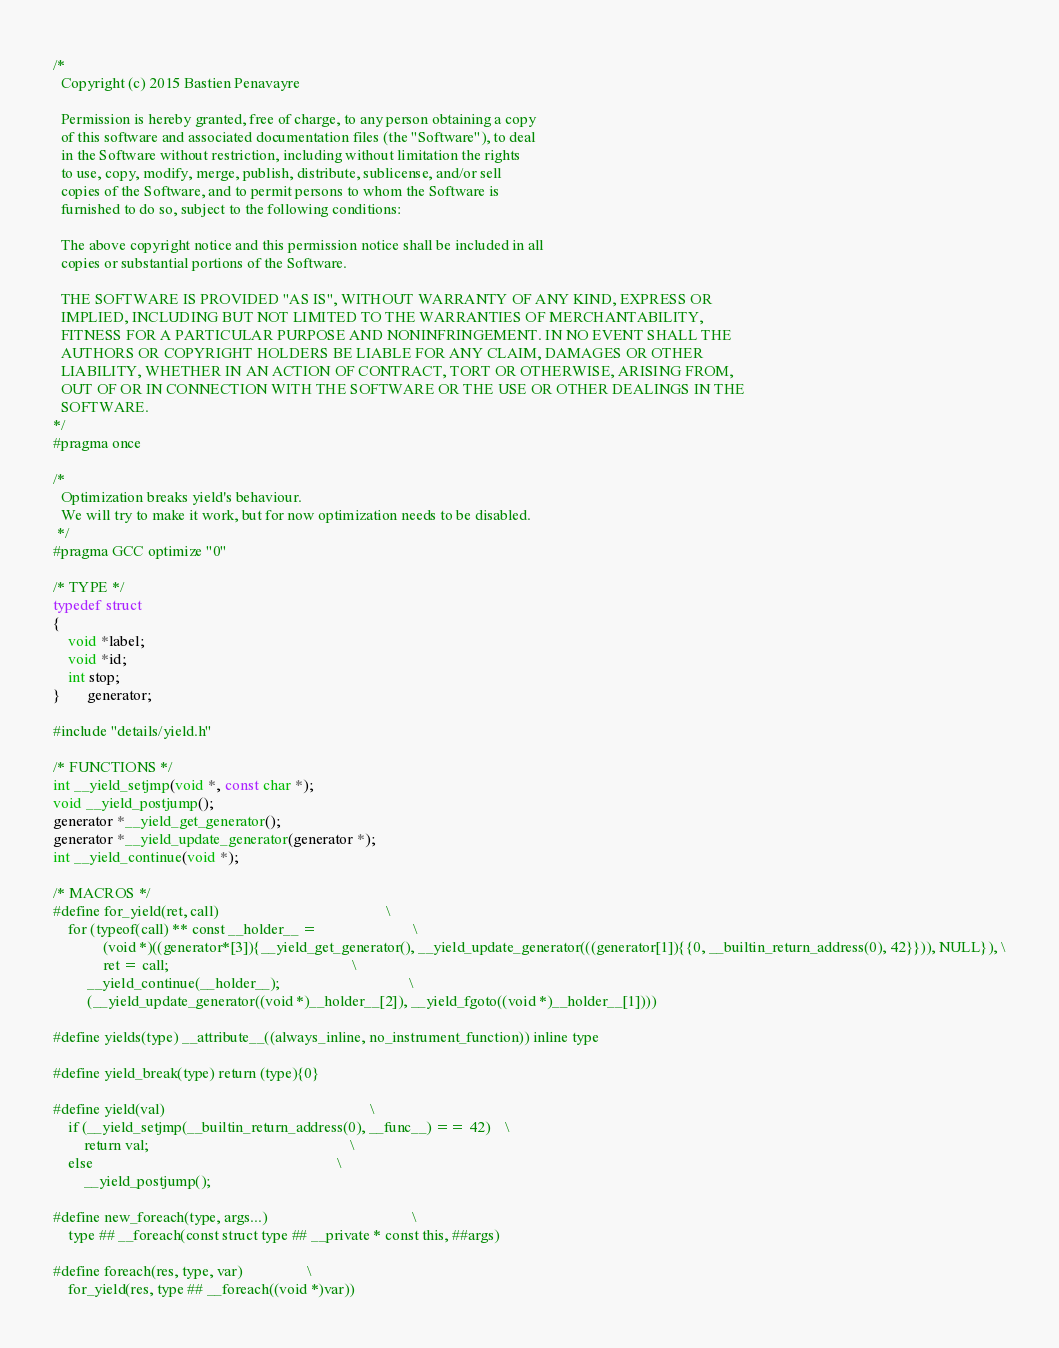<code> <loc_0><loc_0><loc_500><loc_500><_C_>/*
  Copyright (c) 2015 Bastien Penavayre

  Permission is hereby granted, free of charge, to any person obtaining a copy
  of this software and associated documentation files (the "Software"), to deal
  in the Software without restriction, including without limitation the rights
  to use, copy, modify, merge, publish, distribute, sublicense, and/or sell
  copies of the Software, and to permit persons to whom the Software is
  furnished to do so, subject to the following conditions:

  The above copyright notice and this permission notice shall be included in all
  copies or substantial portions of the Software.

  THE SOFTWARE IS PROVIDED "AS IS", WITHOUT WARRANTY OF ANY KIND, EXPRESS OR
  IMPLIED, INCLUDING BUT NOT LIMITED TO THE WARRANTIES OF MERCHANTABILITY,
  FITNESS FOR A PARTICULAR PURPOSE AND NONINFRINGEMENT. IN NO EVENT SHALL THE
  AUTHORS OR COPYRIGHT HOLDERS BE LIABLE FOR ANY CLAIM, DAMAGES OR OTHER
  LIABILITY, WHETHER IN AN ACTION OF CONTRACT, TORT OR OTHERWISE, ARISING FROM,
  OUT OF OR IN CONNECTION WITH THE SOFTWARE OR THE USE OR OTHER DEALINGS IN THE
  SOFTWARE.
*/
#pragma once

/*
  Optimization breaks yield's behaviour.
  We will try to make it work, but for now optimization needs to be disabled.
 */
#pragma GCC optimize "0"

/* TYPE */
typedef struct
{
    void *label;
    void *id;
    int stop;
}       generator;

#include "details/yield.h"

/* FUNCTIONS */
int __yield_setjmp(void *, const char *);
void __yield_postjump();
generator *__yield_get_generator();
generator *__yield_update_generator(generator *);
int __yield_continue(void *);

/* MACROS */
#define for_yield(ret, call)                                            \
    for (typeof(call) ** const __holder__ =                         \
             (void *)((generator*[3]){__yield_get_generator(), __yield_update_generator(((generator[1]){{0, __builtin_return_address(0), 42}})), NULL}), \
             ret = call;                                                \
         __yield_continue(__holder__);                                  \
         (__yield_update_generator((void *)__holder__[2]), __yield_fgoto((void *)__holder__[1])))

#define yields(type) __attribute__((always_inline, no_instrument_function)) inline type

#define yield_break(type) return (type){0}

#define yield(val)                                                      \
    if (__yield_setjmp(__builtin_return_address(0), __func__) == 42)    \
        return val;                                                     \
    else                                                                \
        __yield_postjump();

#define new_foreach(type, args...)                                      \
    type ## __foreach(const struct type ## __private * const this, ##args)

#define foreach(res, type, var)                 \
    for_yield(res, type ## __foreach((void *)var))
</code> 